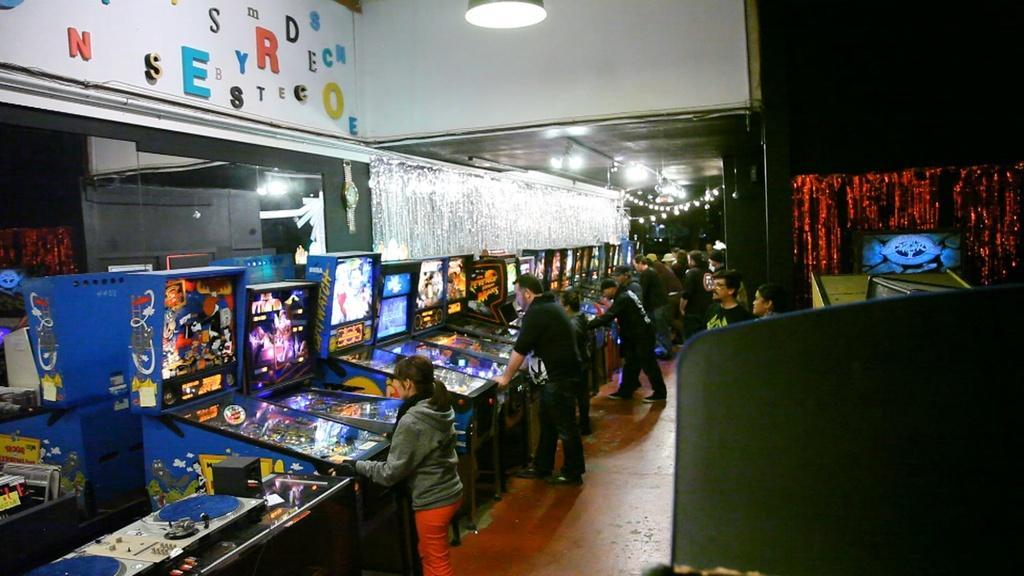Could you give a brief overview of what you see in this image? In this image we can see people are standing on the floor. Here we can see gaming machines, lights, ceiling, and other objects. 